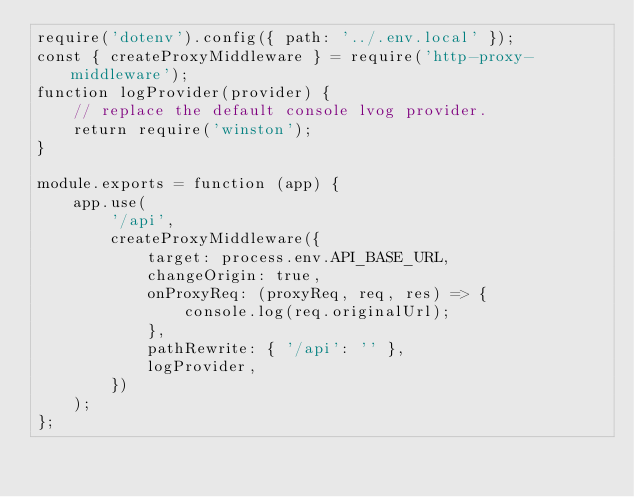Convert code to text. <code><loc_0><loc_0><loc_500><loc_500><_JavaScript_>require('dotenv').config({ path: '../.env.local' });
const { createProxyMiddleware } = require('http-proxy-middleware');
function logProvider(provider) {
    // replace the default console lvog provider.
    return require('winston');
}

module.exports = function (app) {
    app.use(
        '/api',
        createProxyMiddleware({
            target: process.env.API_BASE_URL,
            changeOrigin: true,
            onProxyReq: (proxyReq, req, res) => {
                console.log(req.originalUrl);
            },
            pathRewrite: { '/api': '' },
            logProvider,
        })
    );
};
</code> 